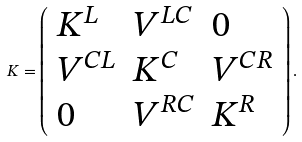Convert formula to latex. <formula><loc_0><loc_0><loc_500><loc_500>K = \left ( \begin{array} { l l l } K ^ { L } & V ^ { L C } & 0 \\ V ^ { C L } & K ^ { C } & V ^ { C R } \\ 0 & V ^ { R C } & K ^ { R } \end{array} \right ) .</formula> 